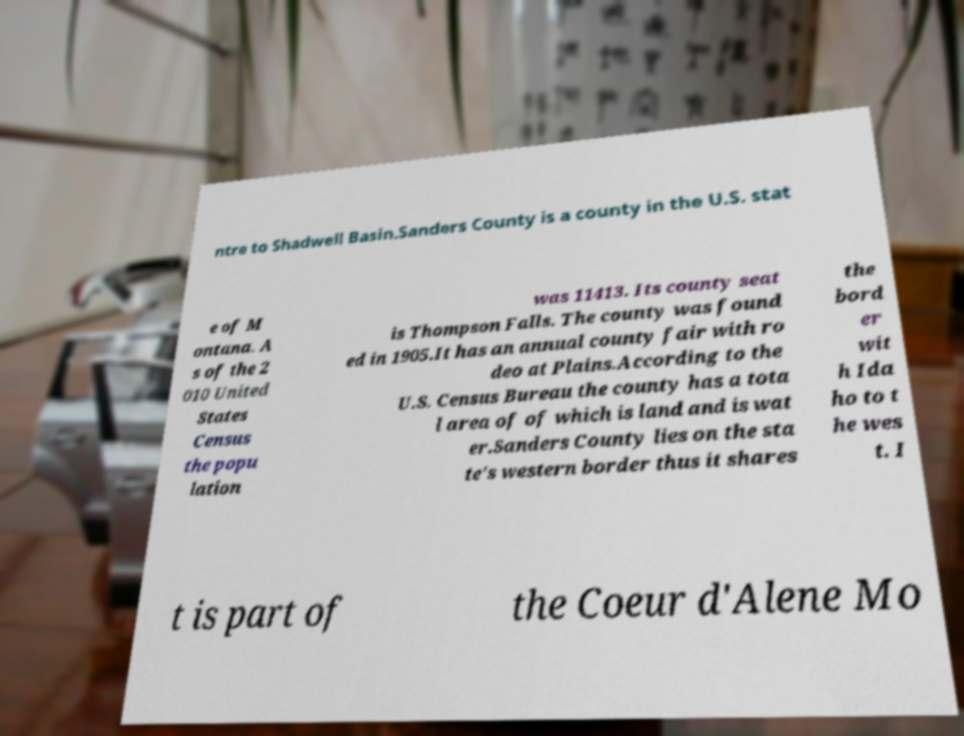Could you extract and type out the text from this image? ntre to Shadwell Basin.Sanders County is a county in the U.S. stat e of M ontana. A s of the 2 010 United States Census the popu lation was 11413. Its county seat is Thompson Falls. The county was found ed in 1905.It has an annual county fair with ro deo at Plains.According to the U.S. Census Bureau the county has a tota l area of of which is land and is wat er.Sanders County lies on the sta te's western border thus it shares the bord er wit h Ida ho to t he wes t. I t is part of the Coeur d'Alene Mo 